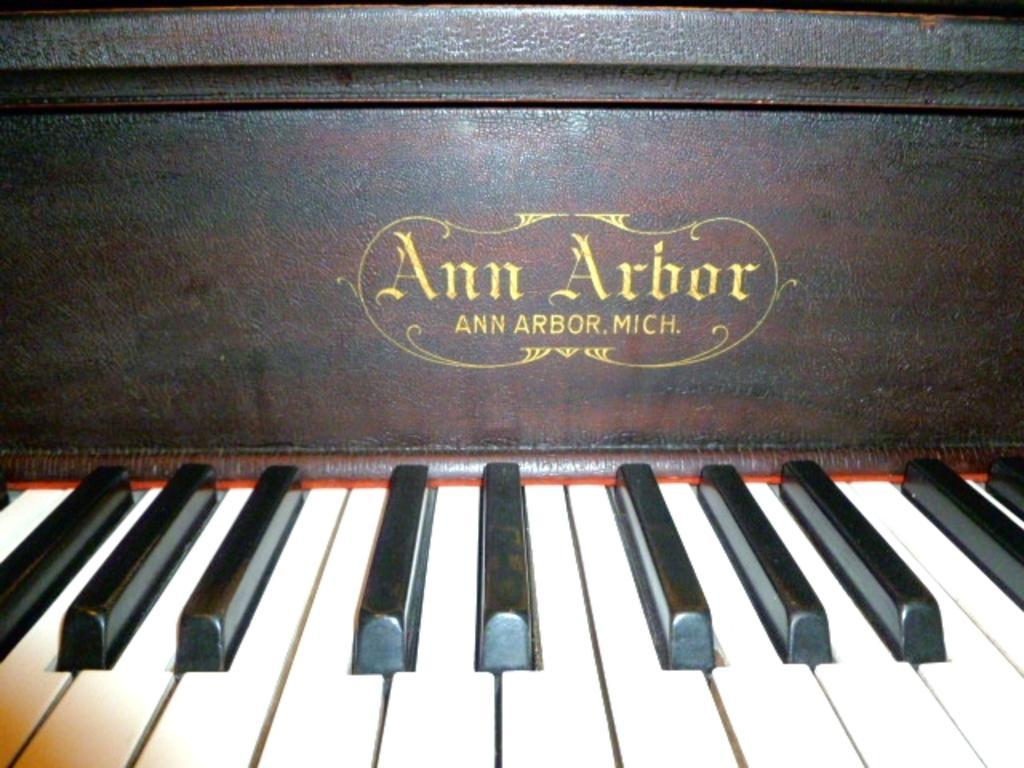Please provide a concise description of this image. Piano keyboard is highlighted in this picture. 